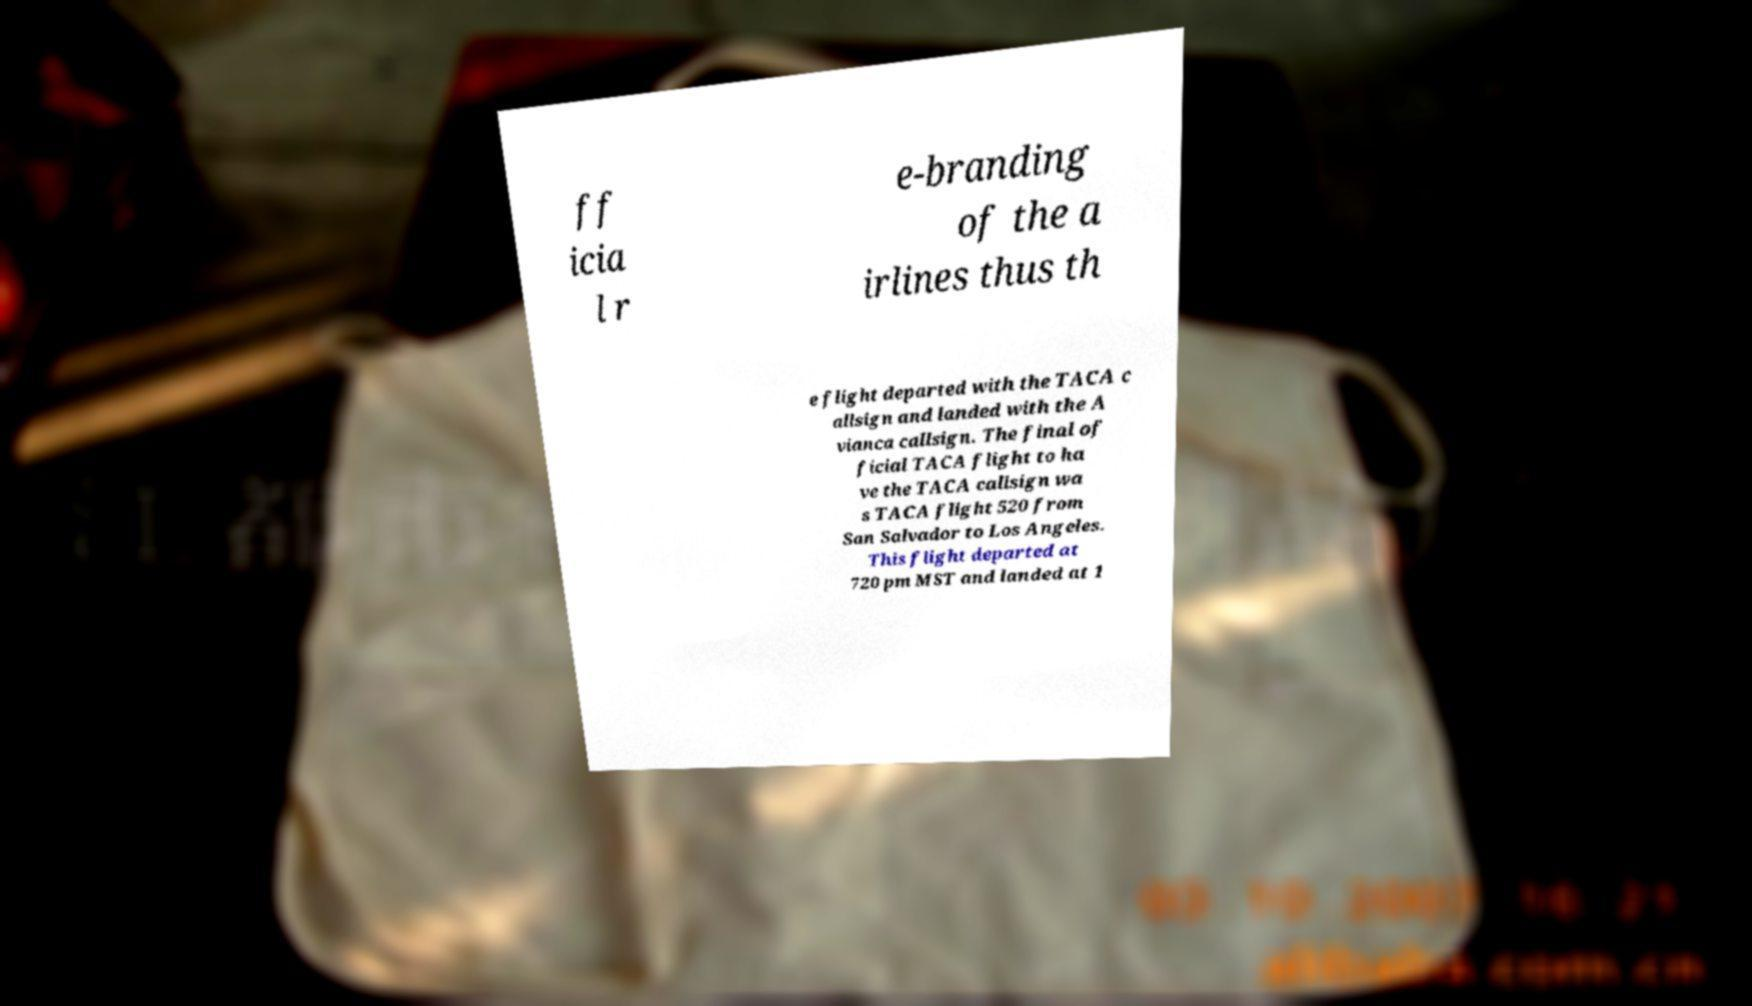Can you read and provide the text displayed in the image?This photo seems to have some interesting text. Can you extract and type it out for me? ff icia l r e-branding of the a irlines thus th e flight departed with the TACA c allsign and landed with the A vianca callsign. The final of ficial TACA flight to ha ve the TACA callsign wa s TACA flight 520 from San Salvador to Los Angeles. This flight departed at 720 pm MST and landed at 1 